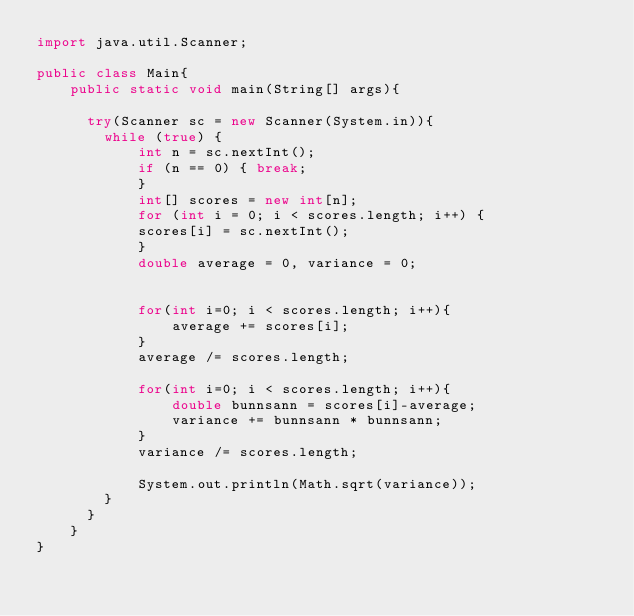Convert code to text. <code><loc_0><loc_0><loc_500><loc_500><_Java_>import java.util.Scanner;
 
public class Main{
    public static void main(String[] args){

      try(Scanner sc = new Scanner(System.in)){
        while (true) {
            int n = sc.nextInt();
            if (n == 0) { break; 
            }
            int[] scores = new int[n];
            for (int i = 0; i < scores.length; i++) {
            scores[i] = sc.nextInt();
            }
            double average = 0, variance = 0;

            
            for(int i=0; i < scores.length; i++){
                average += scores[i];
            }
            average /= scores.length;

            for(int i=0; i < scores.length; i++){
                double bunnsann = scores[i]-average;
                variance += bunnsann * bunnsann;
            }
            variance /= scores.length;

            System.out.println(Math.sqrt(variance));
        }    
      }
    }
}
</code> 